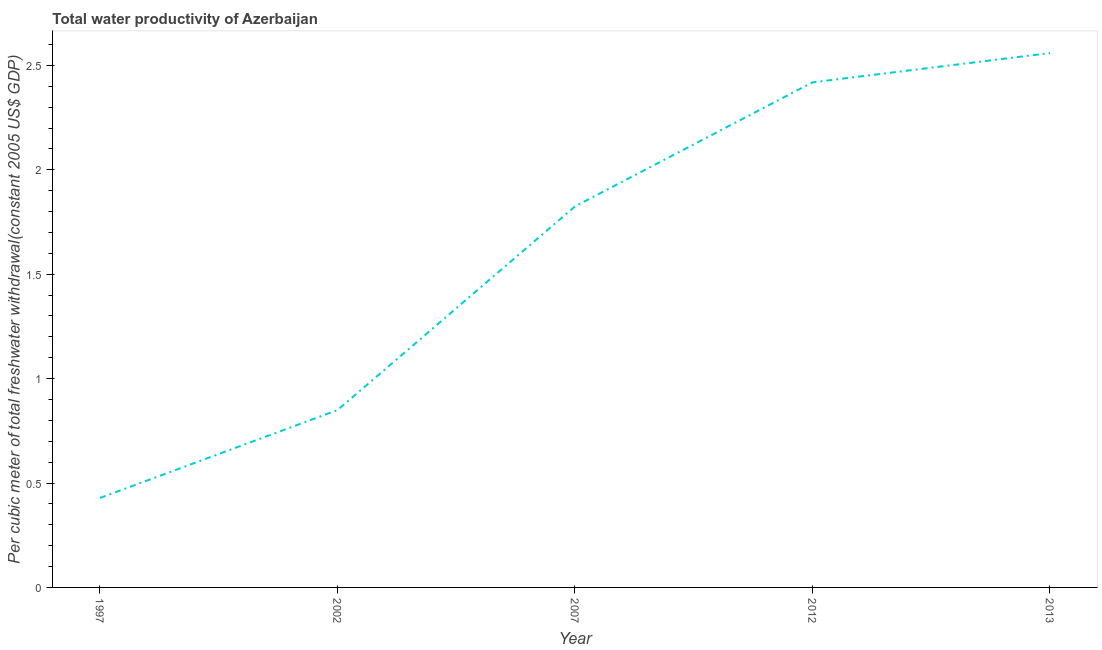What is the total water productivity in 2007?
Keep it short and to the point. 1.82. Across all years, what is the maximum total water productivity?
Ensure brevity in your answer.  2.56. Across all years, what is the minimum total water productivity?
Provide a short and direct response. 0.43. In which year was the total water productivity maximum?
Provide a short and direct response. 2013. In which year was the total water productivity minimum?
Provide a short and direct response. 1997. What is the sum of the total water productivity?
Keep it short and to the point. 8.08. What is the difference between the total water productivity in 2002 and 2013?
Offer a very short reply. -1.71. What is the average total water productivity per year?
Give a very brief answer. 1.62. What is the median total water productivity?
Ensure brevity in your answer.  1.82. In how many years, is the total water productivity greater than 0.30000000000000004 US$?
Provide a succinct answer. 5. What is the ratio of the total water productivity in 2002 to that in 2007?
Offer a very short reply. 0.47. Is the total water productivity in 1997 less than that in 2013?
Ensure brevity in your answer.  Yes. What is the difference between the highest and the second highest total water productivity?
Provide a succinct answer. 0.14. What is the difference between the highest and the lowest total water productivity?
Keep it short and to the point. 2.13. What is the difference between two consecutive major ticks on the Y-axis?
Provide a succinct answer. 0.5. Does the graph contain any zero values?
Provide a short and direct response. No. What is the title of the graph?
Offer a terse response. Total water productivity of Azerbaijan. What is the label or title of the Y-axis?
Keep it short and to the point. Per cubic meter of total freshwater withdrawal(constant 2005 US$ GDP). What is the Per cubic meter of total freshwater withdrawal(constant 2005 US$ GDP) of 1997?
Your response must be concise. 0.43. What is the Per cubic meter of total freshwater withdrawal(constant 2005 US$ GDP) in 2002?
Offer a terse response. 0.85. What is the Per cubic meter of total freshwater withdrawal(constant 2005 US$ GDP) of 2007?
Your answer should be compact. 1.82. What is the Per cubic meter of total freshwater withdrawal(constant 2005 US$ GDP) of 2012?
Keep it short and to the point. 2.42. What is the Per cubic meter of total freshwater withdrawal(constant 2005 US$ GDP) of 2013?
Your answer should be compact. 2.56. What is the difference between the Per cubic meter of total freshwater withdrawal(constant 2005 US$ GDP) in 1997 and 2002?
Make the answer very short. -0.42. What is the difference between the Per cubic meter of total freshwater withdrawal(constant 2005 US$ GDP) in 1997 and 2007?
Offer a very short reply. -1.4. What is the difference between the Per cubic meter of total freshwater withdrawal(constant 2005 US$ GDP) in 1997 and 2012?
Your answer should be compact. -1.99. What is the difference between the Per cubic meter of total freshwater withdrawal(constant 2005 US$ GDP) in 1997 and 2013?
Ensure brevity in your answer.  -2.13. What is the difference between the Per cubic meter of total freshwater withdrawal(constant 2005 US$ GDP) in 2002 and 2007?
Offer a terse response. -0.98. What is the difference between the Per cubic meter of total freshwater withdrawal(constant 2005 US$ GDP) in 2002 and 2012?
Keep it short and to the point. -1.57. What is the difference between the Per cubic meter of total freshwater withdrawal(constant 2005 US$ GDP) in 2002 and 2013?
Ensure brevity in your answer.  -1.71. What is the difference between the Per cubic meter of total freshwater withdrawal(constant 2005 US$ GDP) in 2007 and 2012?
Offer a very short reply. -0.59. What is the difference between the Per cubic meter of total freshwater withdrawal(constant 2005 US$ GDP) in 2007 and 2013?
Your answer should be very brief. -0.73. What is the difference between the Per cubic meter of total freshwater withdrawal(constant 2005 US$ GDP) in 2012 and 2013?
Provide a short and direct response. -0.14. What is the ratio of the Per cubic meter of total freshwater withdrawal(constant 2005 US$ GDP) in 1997 to that in 2002?
Offer a terse response. 0.51. What is the ratio of the Per cubic meter of total freshwater withdrawal(constant 2005 US$ GDP) in 1997 to that in 2007?
Your answer should be very brief. 0.23. What is the ratio of the Per cubic meter of total freshwater withdrawal(constant 2005 US$ GDP) in 1997 to that in 2012?
Your answer should be very brief. 0.18. What is the ratio of the Per cubic meter of total freshwater withdrawal(constant 2005 US$ GDP) in 1997 to that in 2013?
Your response must be concise. 0.17. What is the ratio of the Per cubic meter of total freshwater withdrawal(constant 2005 US$ GDP) in 2002 to that in 2007?
Keep it short and to the point. 0.47. What is the ratio of the Per cubic meter of total freshwater withdrawal(constant 2005 US$ GDP) in 2002 to that in 2012?
Your answer should be very brief. 0.35. What is the ratio of the Per cubic meter of total freshwater withdrawal(constant 2005 US$ GDP) in 2002 to that in 2013?
Ensure brevity in your answer.  0.33. What is the ratio of the Per cubic meter of total freshwater withdrawal(constant 2005 US$ GDP) in 2007 to that in 2012?
Offer a very short reply. 0.75. What is the ratio of the Per cubic meter of total freshwater withdrawal(constant 2005 US$ GDP) in 2007 to that in 2013?
Make the answer very short. 0.71. What is the ratio of the Per cubic meter of total freshwater withdrawal(constant 2005 US$ GDP) in 2012 to that in 2013?
Provide a succinct answer. 0.94. 